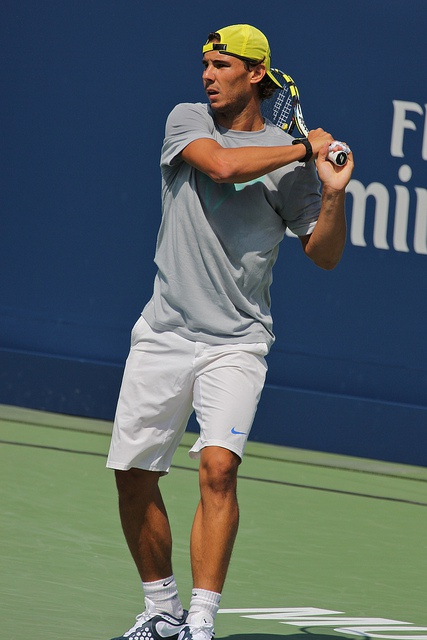Describe the objects in this image and their specific colors. I can see people in navy, darkgray, lightgray, black, and gray tones and tennis racket in navy, black, darkgray, and gray tones in this image. 